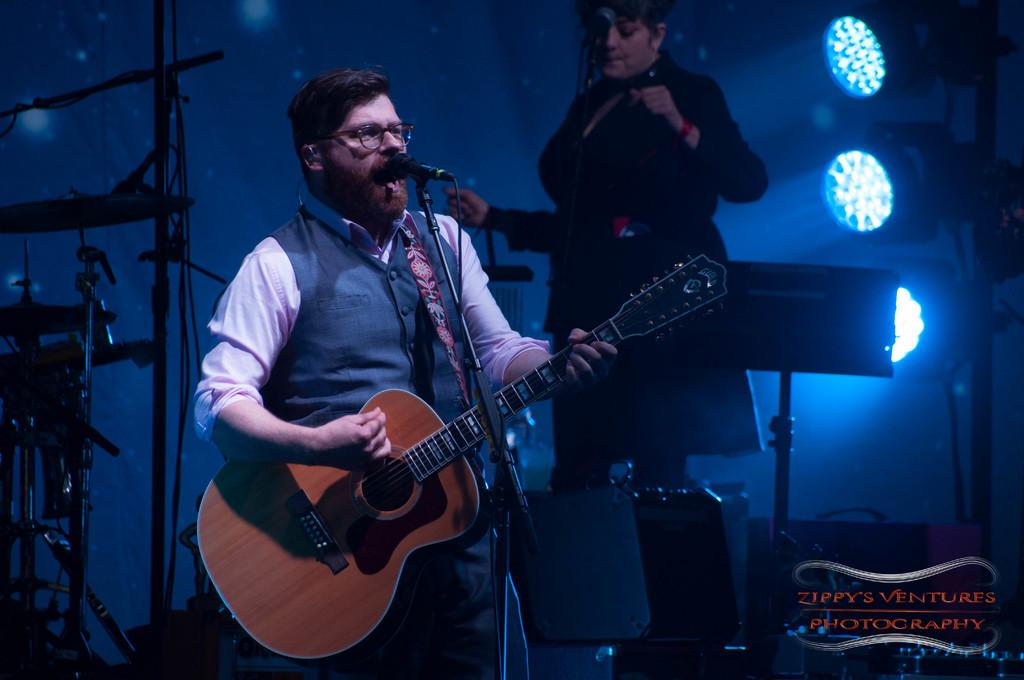What is the man in the image doing? The man is playing a guitar and singing in the image. What object is the man using to amplify his voice? The man is in front of a microphone. Who else is present in the image? There is a woman standing in the image. What can be seen behind the woman? There are focusing lights behind the woman. What type of grain is being harvested in the background of the image? There is no grain or harvesting activity present in the image. 